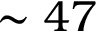<formula> <loc_0><loc_0><loc_500><loc_500>\sim 4 7</formula> 